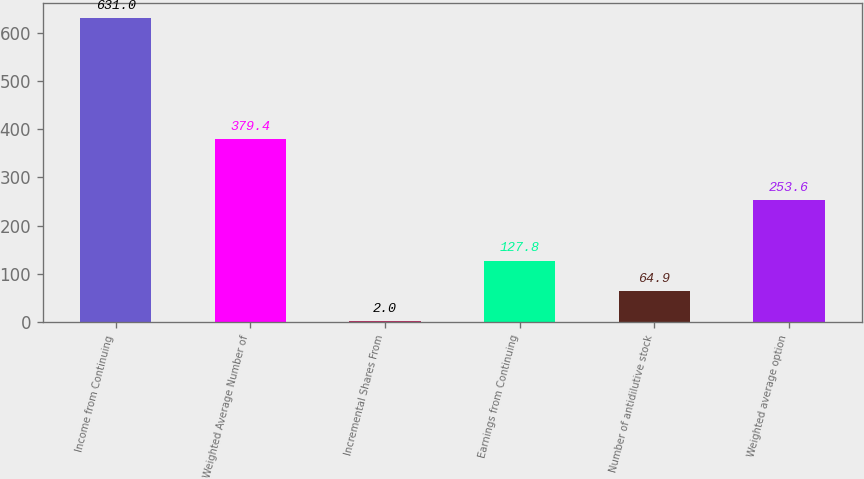<chart> <loc_0><loc_0><loc_500><loc_500><bar_chart><fcel>Income from Continuing<fcel>Weighted Average Number of<fcel>Incremental Shares From<fcel>Earnings from Continuing<fcel>Number of antidilutive stock<fcel>Weighted average option<nl><fcel>631<fcel>379.4<fcel>2<fcel>127.8<fcel>64.9<fcel>253.6<nl></chart> 